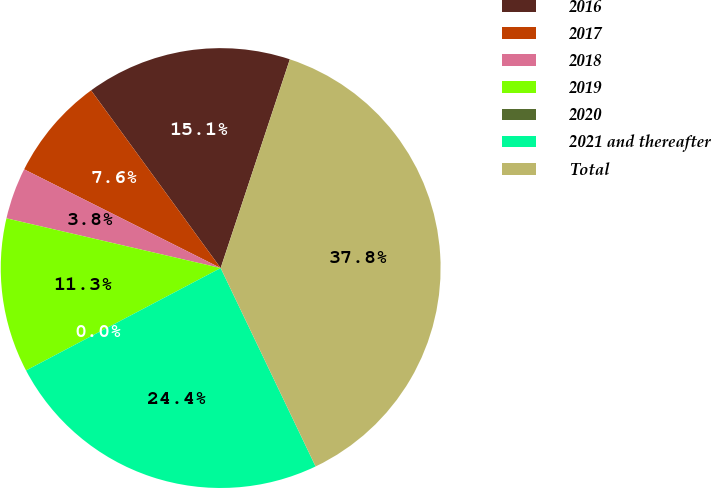<chart> <loc_0><loc_0><loc_500><loc_500><pie_chart><fcel>2016<fcel>2017<fcel>2018<fcel>2019<fcel>2020<fcel>2021 and thereafter<fcel>Total<nl><fcel>15.12%<fcel>7.56%<fcel>3.78%<fcel>11.34%<fcel>0.0%<fcel>24.39%<fcel>37.8%<nl></chart> 